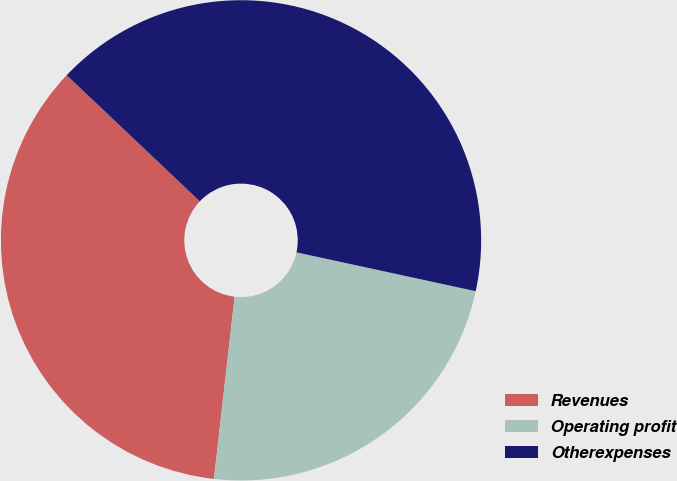Convert chart to OTSL. <chart><loc_0><loc_0><loc_500><loc_500><pie_chart><fcel>Revenues<fcel>Operating profit<fcel>Otherexpenses<nl><fcel>35.27%<fcel>23.4%<fcel>41.33%<nl></chart> 